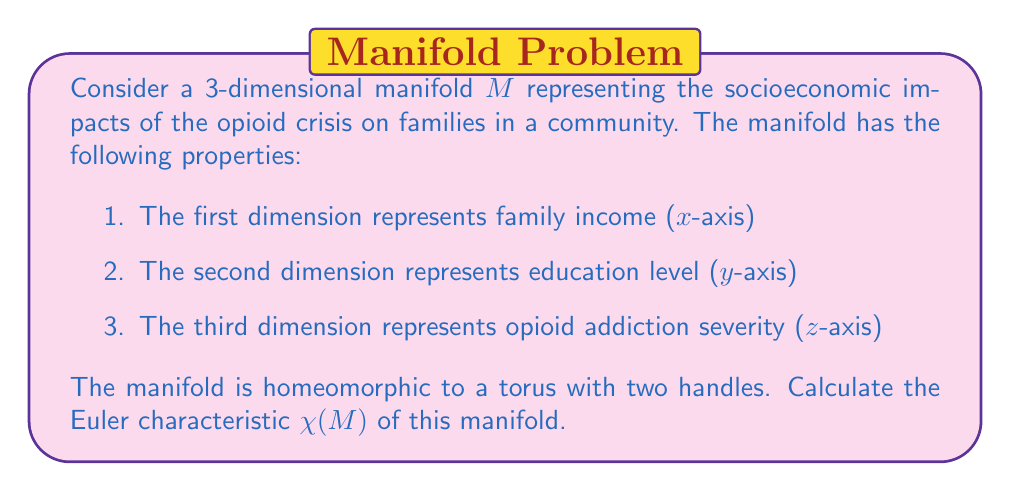Could you help me with this problem? To solve this problem, we need to understand the relationship between the topology of the manifold and its Euler characteristic. The steps to calculate the Euler characteristic are as follows:

1. Recall the formula for the Euler characteristic of a surface:
   $$\chi = V - E + F$$
   where V is the number of vertices, E is the number of edges, and F is the number of faces in a triangulation of the surface.

2. For a closed orientable surface of genus g, the Euler characteristic is given by:
   $$\chi = 2 - 2g$$
   where g is the genus (number of handles) of the surface.

3. In this case, we have a torus with two handles, which means the genus g = 3.

4. Substituting g = 3 into the formula:
   $$\chi = 2 - 2(3) = 2 - 6 = -4$$

5. We can verify this result by considering the topology of the manifold:
   - A torus has Euler characteristic 0
   - Each additional handle decreases the Euler characteristic by 2
   - With two additional handles: 0 - 2 - 2 = -4

Therefore, the Euler characteristic of the manifold M is -4.

This negative Euler characteristic indicates a complex topology, reflecting the intricate relationships between family income, education level, and opioid addiction severity in the community. The multiple handles in the manifold represent the various pathways and cycles that families may experience in relation to the opioid crisis.
Answer: $\chi(M) = -4$ 